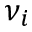<formula> <loc_0><loc_0><loc_500><loc_500>\nu _ { i }</formula> 